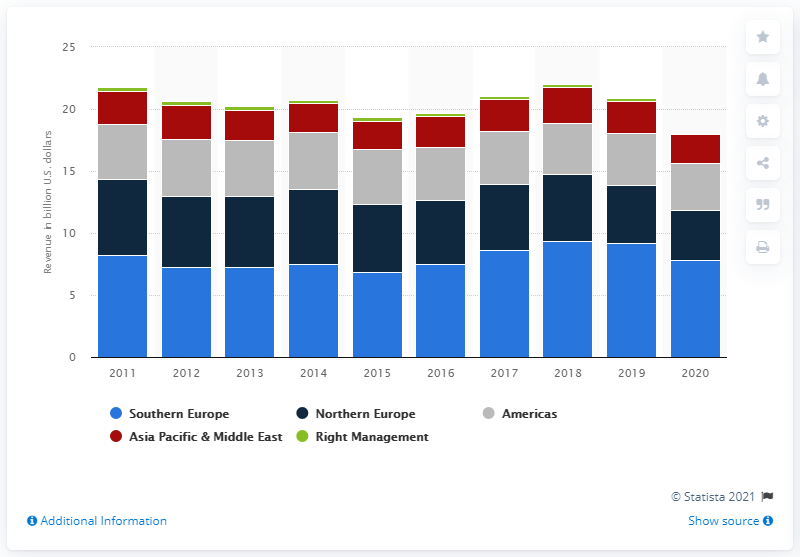Identify some key points in this picture. The revenue of Manpower Group in Asia, the Pacific, and the Middle East in 2020 was 2.38 billion. 